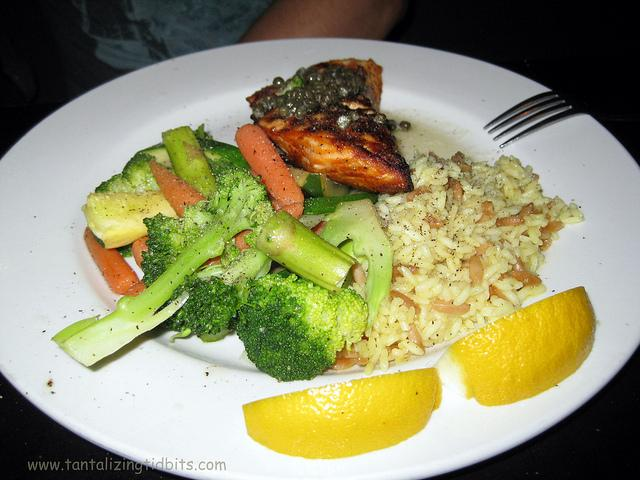What type of dish is this? dinner 